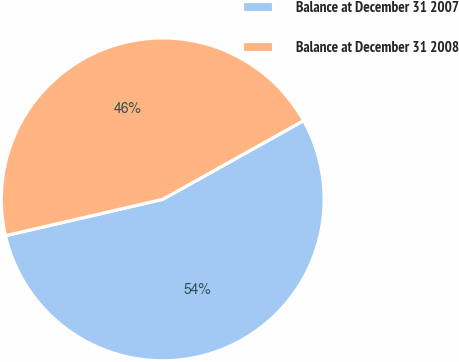Convert chart to OTSL. <chart><loc_0><loc_0><loc_500><loc_500><pie_chart><fcel>Balance at December 31 2007<fcel>Balance at December 31 2008<nl><fcel>54.49%<fcel>45.51%<nl></chart> 